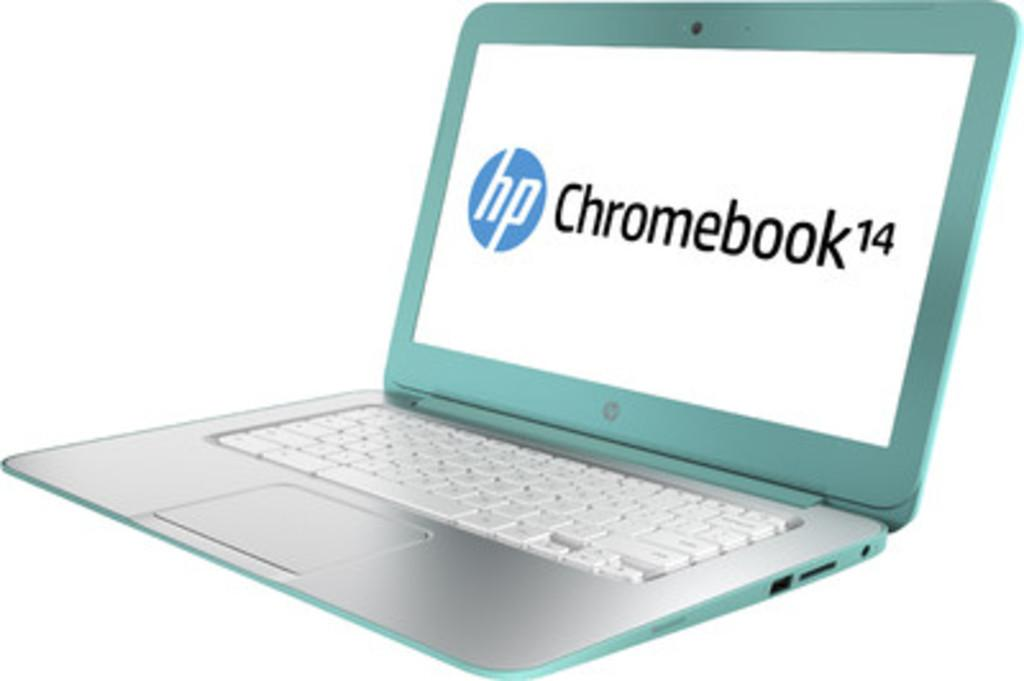<image>
Render a clear and concise summary of the photo. An open teal colored HP Chromebook laptop computer. 